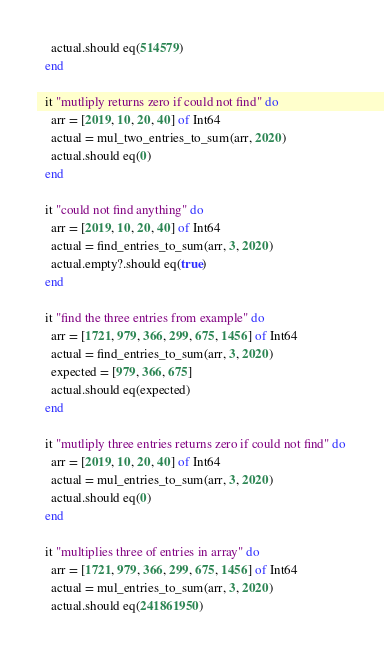<code> <loc_0><loc_0><loc_500><loc_500><_Crystal_>    actual.should eq(514579)
  end

  it "mutliply returns zero if could not find" do
    arr = [2019, 10, 20, 40] of Int64
    actual = mul_two_entries_to_sum(arr, 2020)
    actual.should eq(0)
  end

  it "could not find anything" do
    arr = [2019, 10, 20, 40] of Int64
    actual = find_entries_to_sum(arr, 3, 2020)
    actual.empty?.should eq(true)
  end

  it "find the three entries from example" do
    arr = [1721, 979, 366, 299, 675, 1456] of Int64
    actual = find_entries_to_sum(arr, 3, 2020)
    expected = [979, 366, 675]
    actual.should eq(expected)
  end

  it "mutliply three entries returns zero if could not find" do
    arr = [2019, 10, 20, 40] of Int64
    actual = mul_entries_to_sum(arr, 3, 2020)
    actual.should eq(0)
  end

  it "multiplies three of entries in array" do
    arr = [1721, 979, 366, 299, 675, 1456] of Int64
    actual = mul_entries_to_sum(arr, 3, 2020)
    actual.should eq(241861950)</code> 